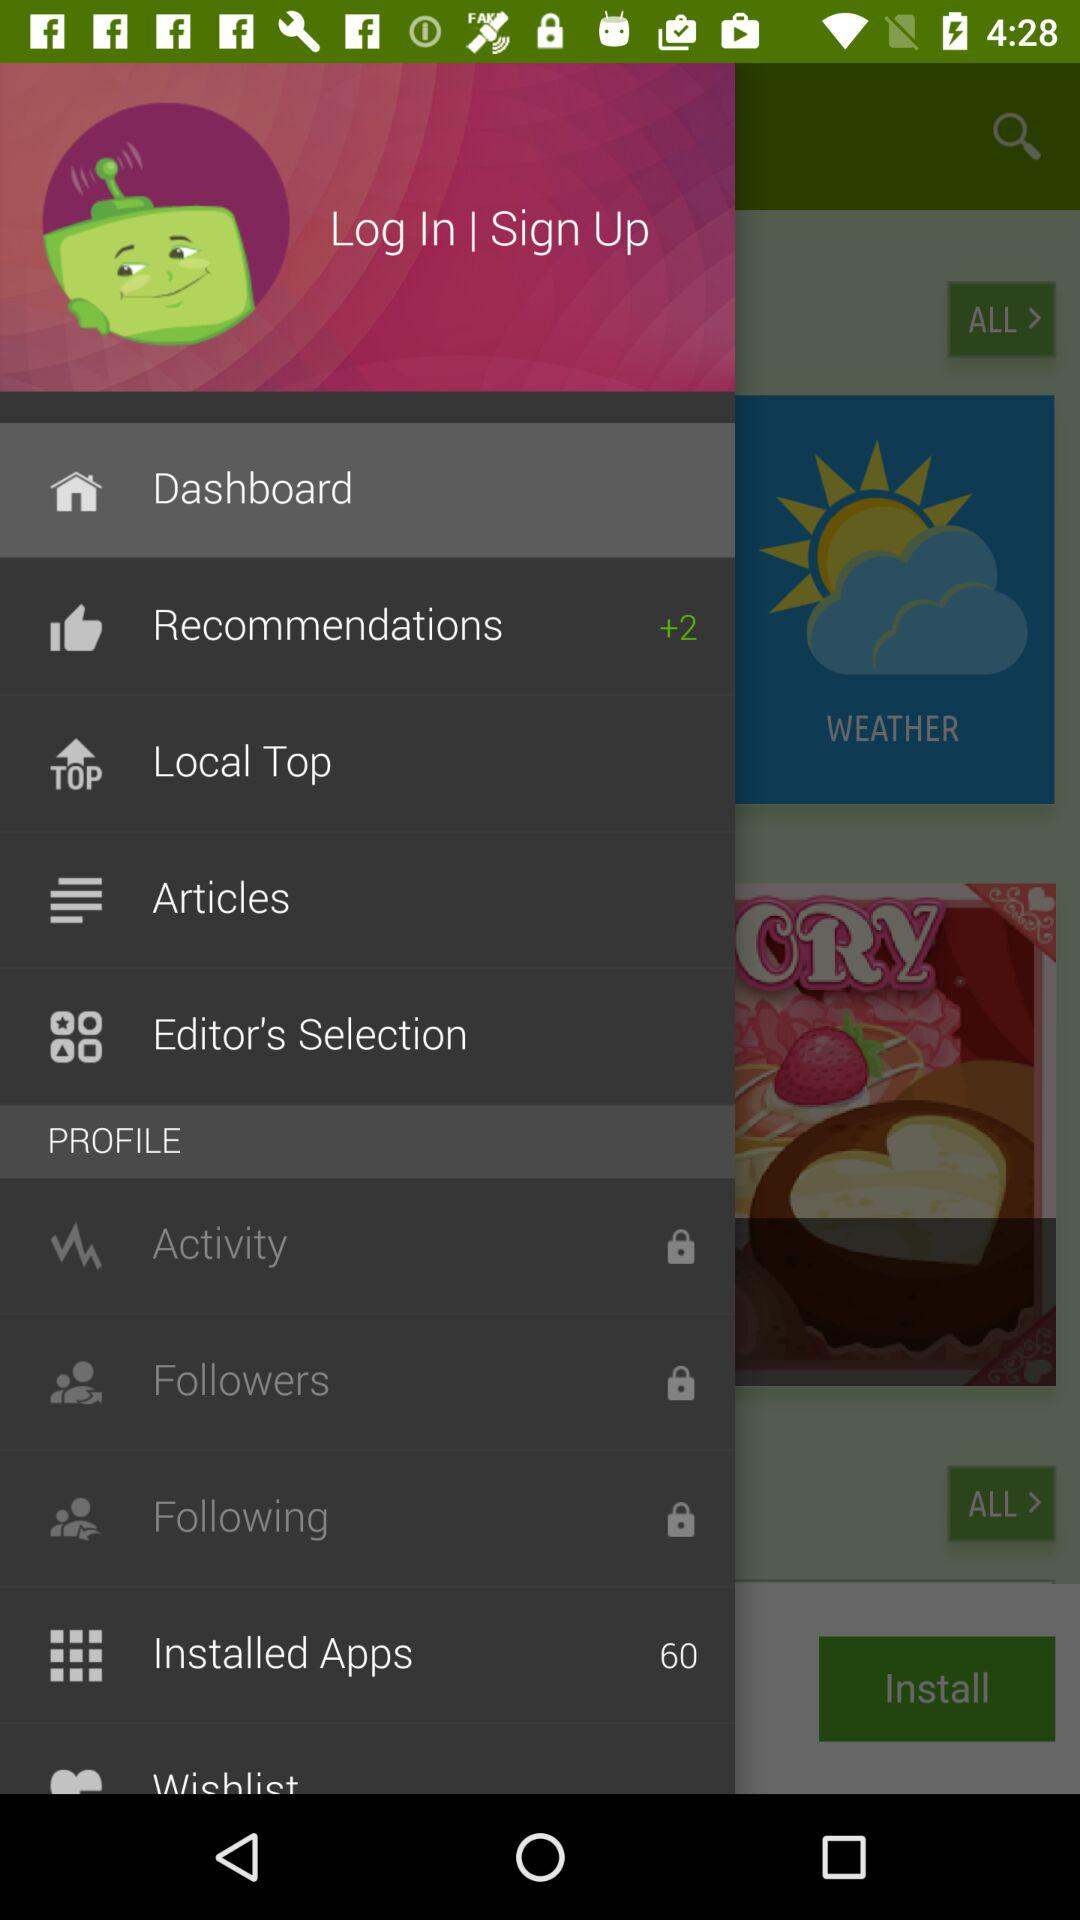How many installed apps are there? There are 60 installed apps. 